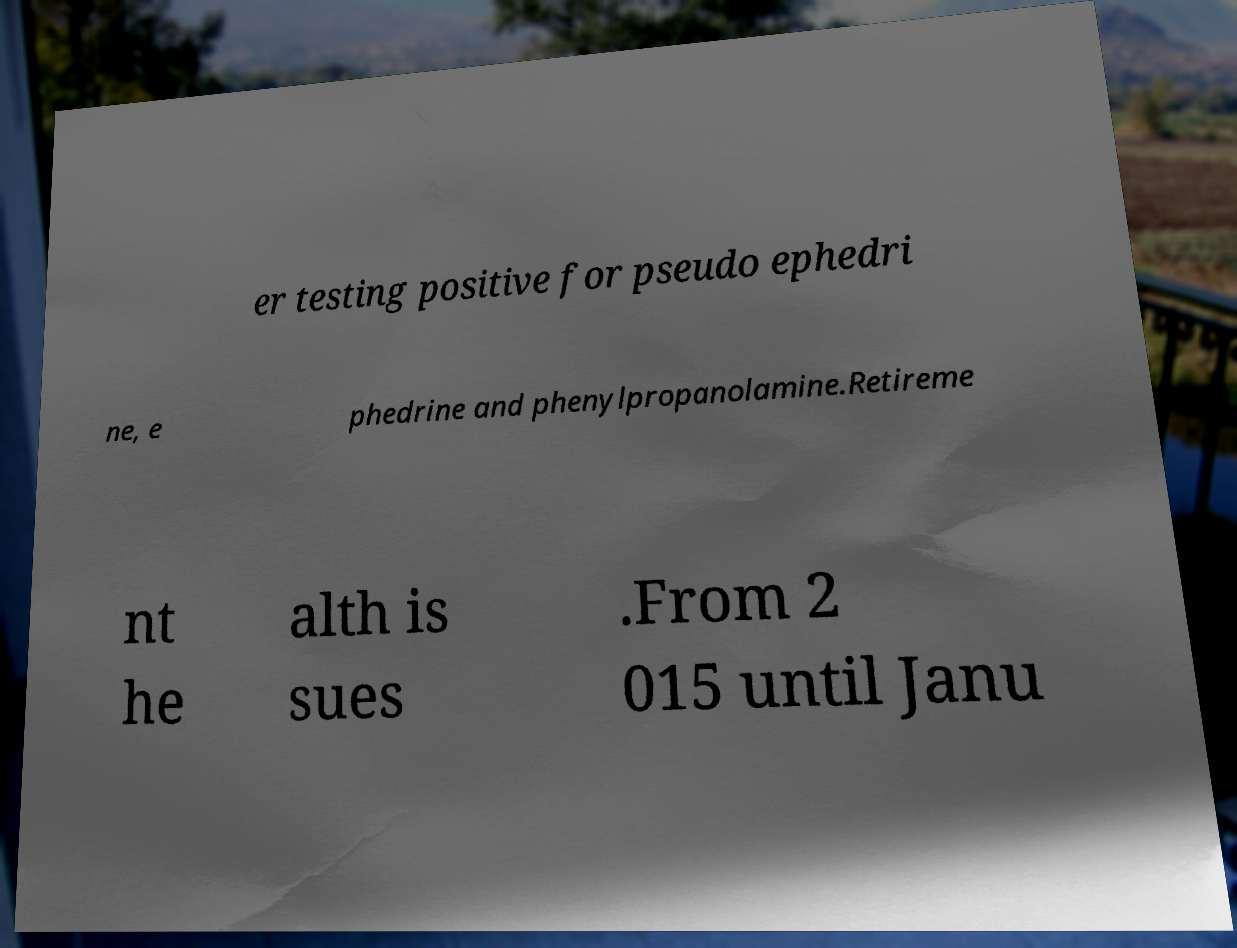For documentation purposes, I need the text within this image transcribed. Could you provide that? er testing positive for pseudo ephedri ne, e phedrine and phenylpropanolamine.Retireme nt he alth is sues .From 2 015 until Janu 